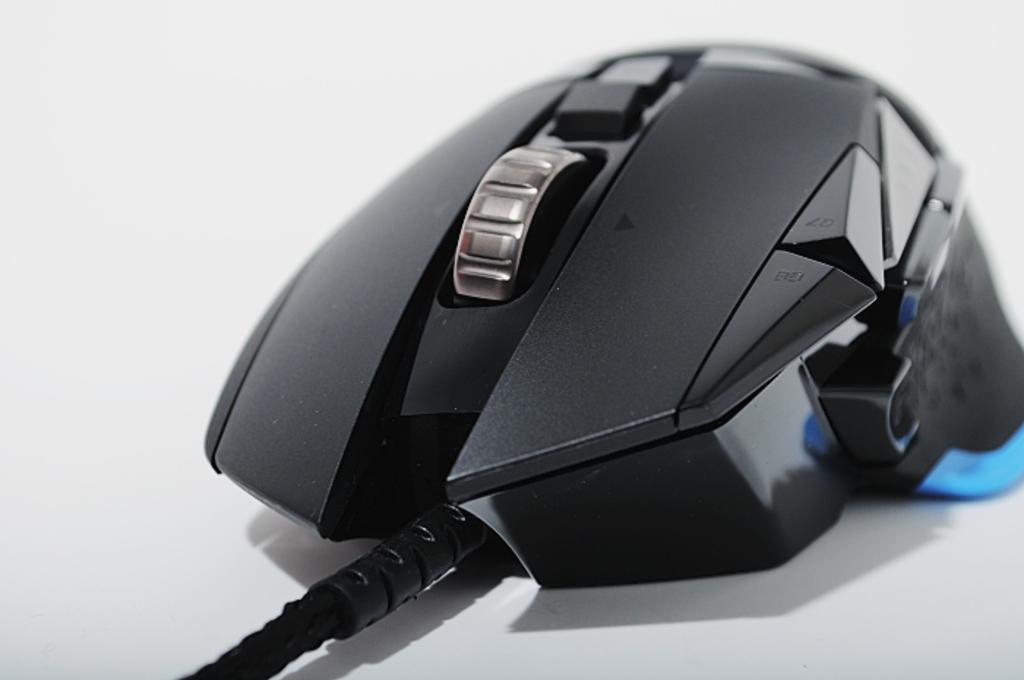Describe this image in one or two sentences. We can see mouse with cable on the white platform. In the background it is white. 